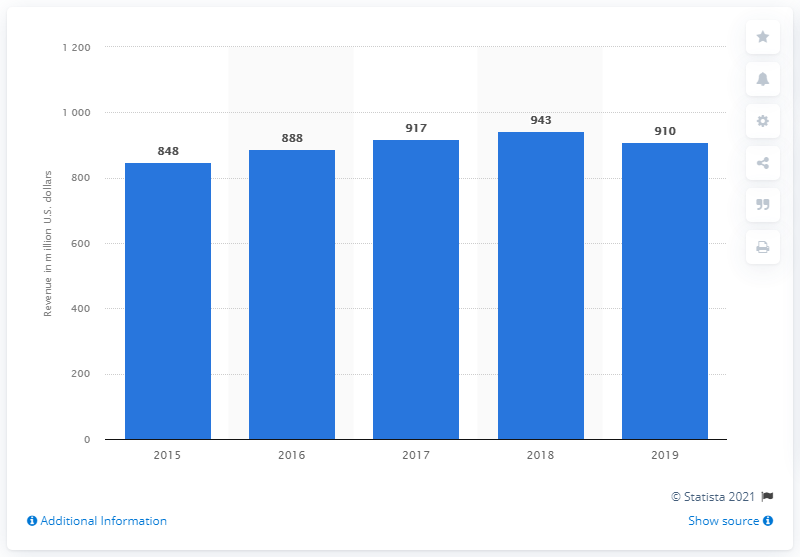Specify some key components in this picture. The amount of dollars spent on TV advertising during March Madness in 2019 was approximately $910. 